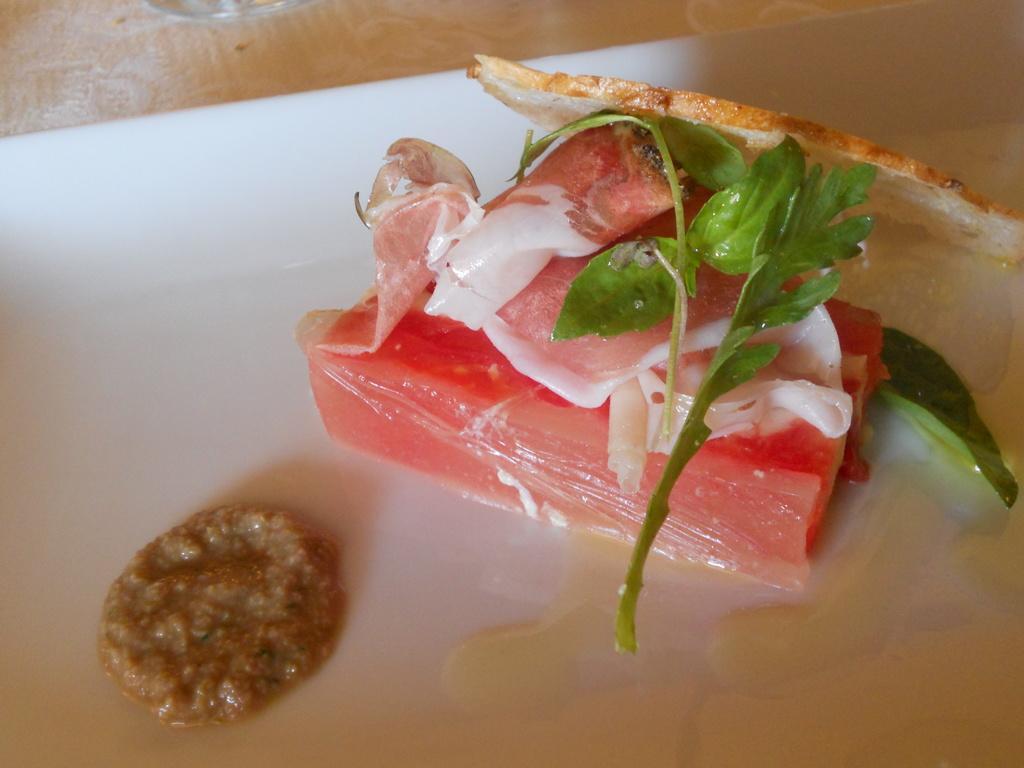In one or two sentences, can you explain what this image depicts? In this picture we can see some food items in the white plate and the plate is on an object. 